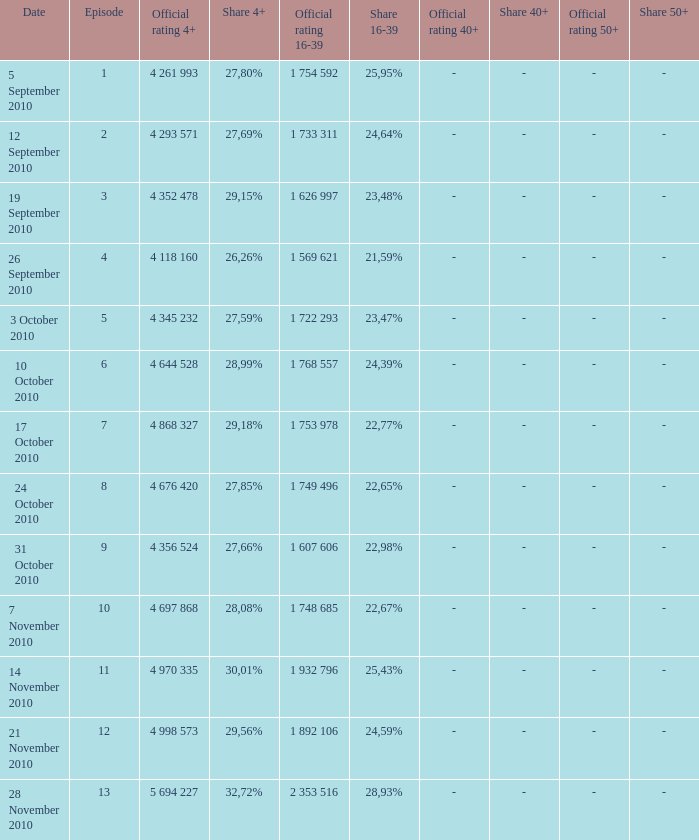What is the 16-39 share of the episode with a 4+ share of 30,01%? 25,43%. 